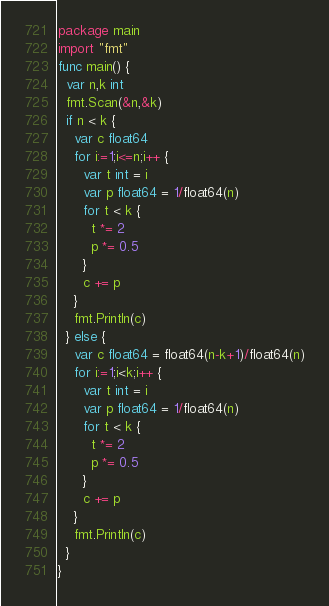<code> <loc_0><loc_0><loc_500><loc_500><_Go_>package main
import "fmt"
func main() {
  var n,k int
  fmt.Scan(&n,&k)
  if n < k {
    var c float64
    for i:=1;i<=n;i++ {
      var t int = i
      var p float64 = 1/float64(n)
      for t < k {
        t *= 2
        p *= 0.5
      }
      c += p
    }
    fmt.Println(c)
  } else {
    var c float64 = float64(n-k+1)/float64(n)
    for i:=1;i<k;i++ {
      var t int = i
      var p float64 = 1/float64(n)
      for t < k {
        t *= 2
        p *= 0.5
      }
      c += p
    }
    fmt.Println(c)
  }
}</code> 